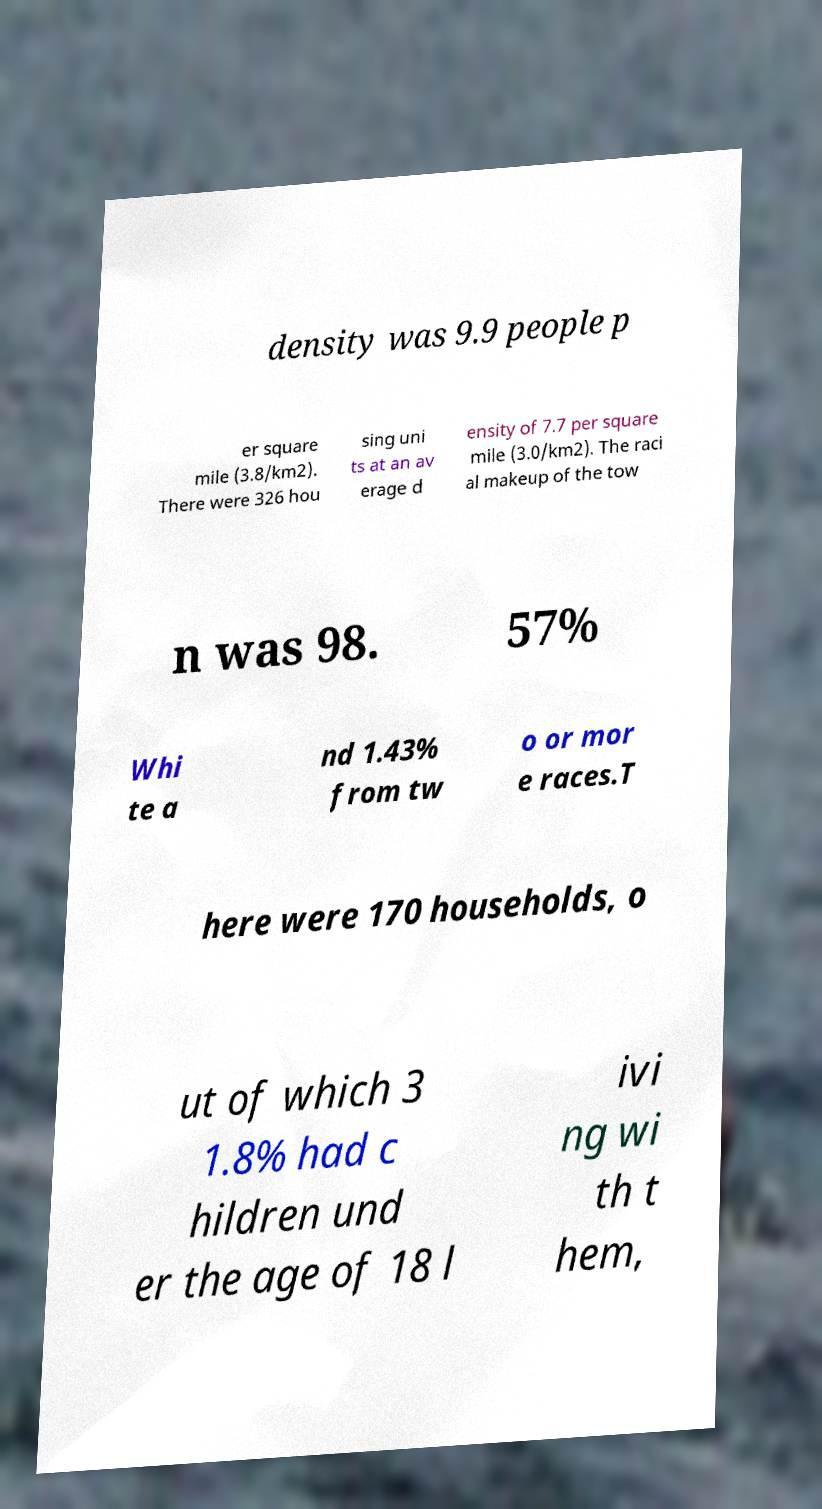What messages or text are displayed in this image? I need them in a readable, typed format. density was 9.9 people p er square mile (3.8/km2). There were 326 hou sing uni ts at an av erage d ensity of 7.7 per square mile (3.0/km2). The raci al makeup of the tow n was 98. 57% Whi te a nd 1.43% from tw o or mor e races.T here were 170 households, o ut of which 3 1.8% had c hildren und er the age of 18 l ivi ng wi th t hem, 